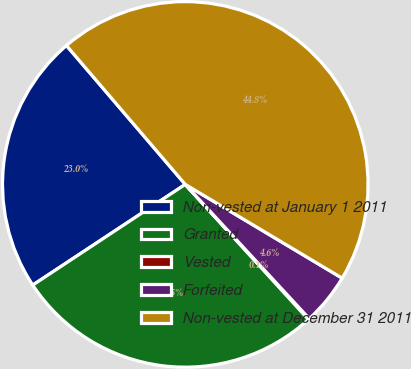Convert chart to OTSL. <chart><loc_0><loc_0><loc_500><loc_500><pie_chart><fcel>Non-vested at January 1 2011<fcel>Granted<fcel>Vested<fcel>Forfeited<fcel>Non-vested at December 31 2011<nl><fcel>23.02%<fcel>27.49%<fcel>0.09%<fcel>4.56%<fcel>44.84%<nl></chart> 